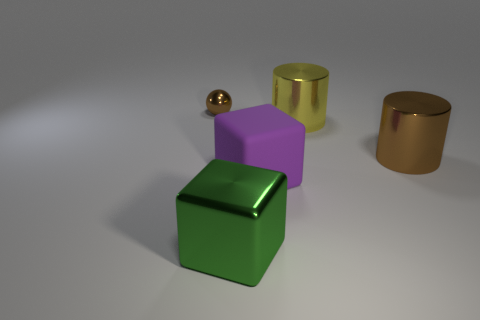There is a brown metallic thing left of the large purple object; is it the same size as the brown thing that is on the right side of the large matte cube?
Give a very brief answer. No. What number of large objects are the same color as the tiny object?
Your answer should be very brief. 1. There is a brown object to the right of the big purple rubber block; how big is it?
Provide a succinct answer. Large. What shape is the brown object in front of the small metallic thing behind the big metallic object that is in front of the brown cylinder?
Offer a terse response. Cylinder. What shape is the thing that is behind the brown shiny cylinder and in front of the metallic ball?
Provide a short and direct response. Cylinder. Are there any green shiny objects that have the same size as the purple block?
Keep it short and to the point. Yes. Do the thing that is in front of the purple block and the purple thing have the same shape?
Keep it short and to the point. Yes. Does the purple object have the same shape as the small brown thing?
Your response must be concise. No. Is there a small metal object of the same shape as the big yellow thing?
Offer a terse response. No. What shape is the thing that is on the left side of the large shiny thing that is on the left side of the purple rubber block?
Your answer should be compact. Sphere. 